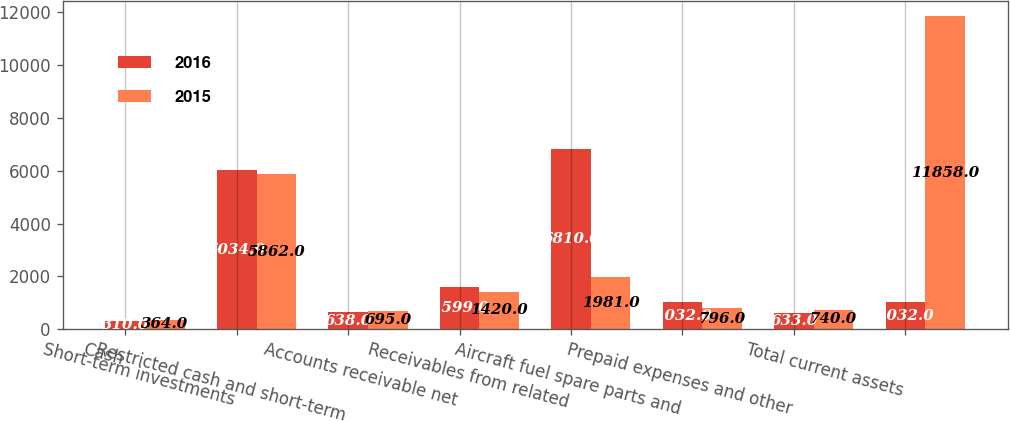<chart> <loc_0><loc_0><loc_500><loc_500><stacked_bar_chart><ecel><fcel>Cash<fcel>Short-term investments<fcel>Restricted cash and short-term<fcel>Accounts receivable net<fcel>Receivables from related<fcel>Aircraft fuel spare parts and<fcel>Prepaid expenses and other<fcel>Total current assets<nl><fcel>2016<fcel>310<fcel>6034<fcel>638<fcel>1599<fcel>6810<fcel>1032<fcel>633<fcel>1032<nl><fcel>2015<fcel>364<fcel>5862<fcel>695<fcel>1420<fcel>1981<fcel>796<fcel>740<fcel>11858<nl></chart> 